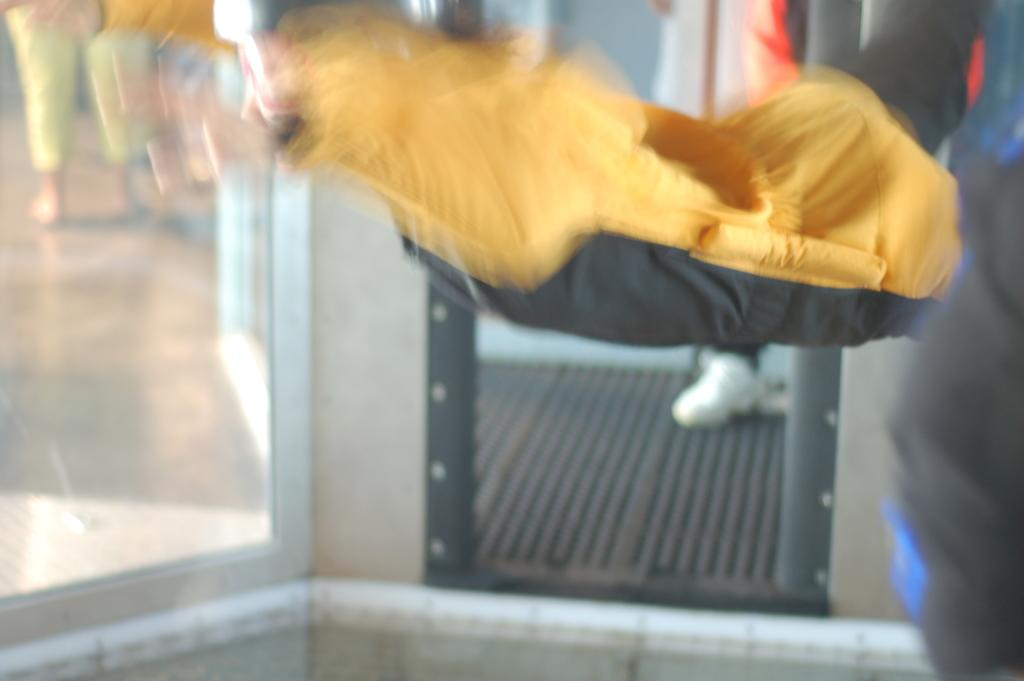Who or what can be seen in the image? There are people in the image. What object is present in the image along with the people? There is a glass in the image. What type of shoes are the people wearing in the image? There is no information about shoes in the image, as the facts provided only mention the presence of people and a glass. 